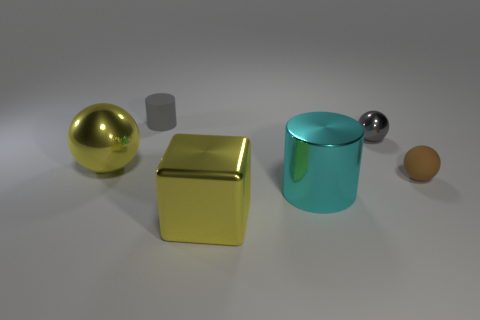Is there a purple matte thing that has the same size as the cyan metallic cylinder?
Offer a terse response. No. There is a yellow ball that is the same size as the metal cube; what is it made of?
Make the answer very short. Metal. What number of metallic objects are there?
Your response must be concise. 4. There is a rubber thing behind the gray metal sphere; what is its size?
Provide a short and direct response. Small. Are there an equal number of big yellow shiny balls that are right of the brown rubber ball and gray things?
Your response must be concise. No. Are there any tiny purple matte objects that have the same shape as the tiny gray rubber object?
Offer a very short reply. No. There is a metal object that is both on the right side of the yellow ball and behind the cyan cylinder; what shape is it?
Offer a very short reply. Sphere. Is the large cylinder made of the same material as the gray thing right of the metallic cylinder?
Your response must be concise. Yes. There is a yellow block; are there any tiny matte spheres on the left side of it?
Keep it short and to the point. No. What number of things are either large yellow blocks or matte objects that are behind the small metallic sphere?
Your response must be concise. 2. 